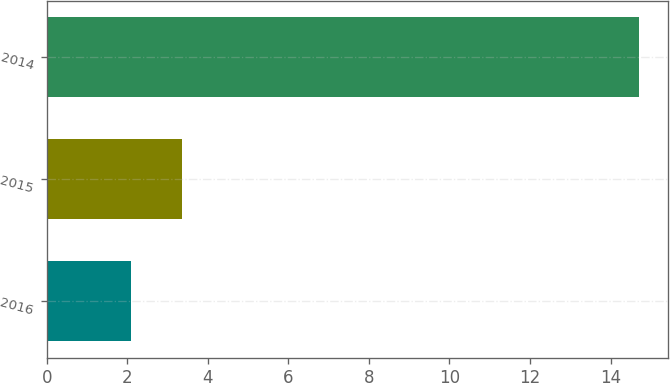Convert chart. <chart><loc_0><loc_0><loc_500><loc_500><bar_chart><fcel>2016<fcel>2015<fcel>2014<nl><fcel>2.1<fcel>3.36<fcel>14.7<nl></chart> 